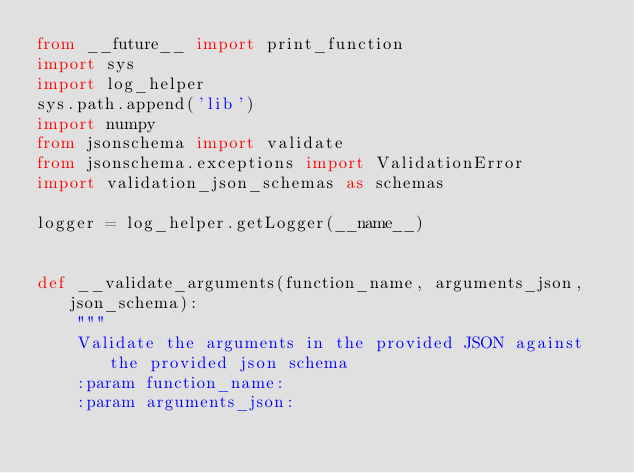<code> <loc_0><loc_0><loc_500><loc_500><_Python_>from __future__ import print_function
import sys
import log_helper
sys.path.append('lib')
import numpy
from jsonschema import validate
from jsonschema.exceptions import ValidationError
import validation_json_schemas as schemas

logger = log_helper.getLogger(__name__)


def __validate_arguments(function_name, arguments_json, json_schema):
    """
    Validate the arguments in the provided JSON against the provided json schema
    :param function_name:
    :param arguments_json:</code> 